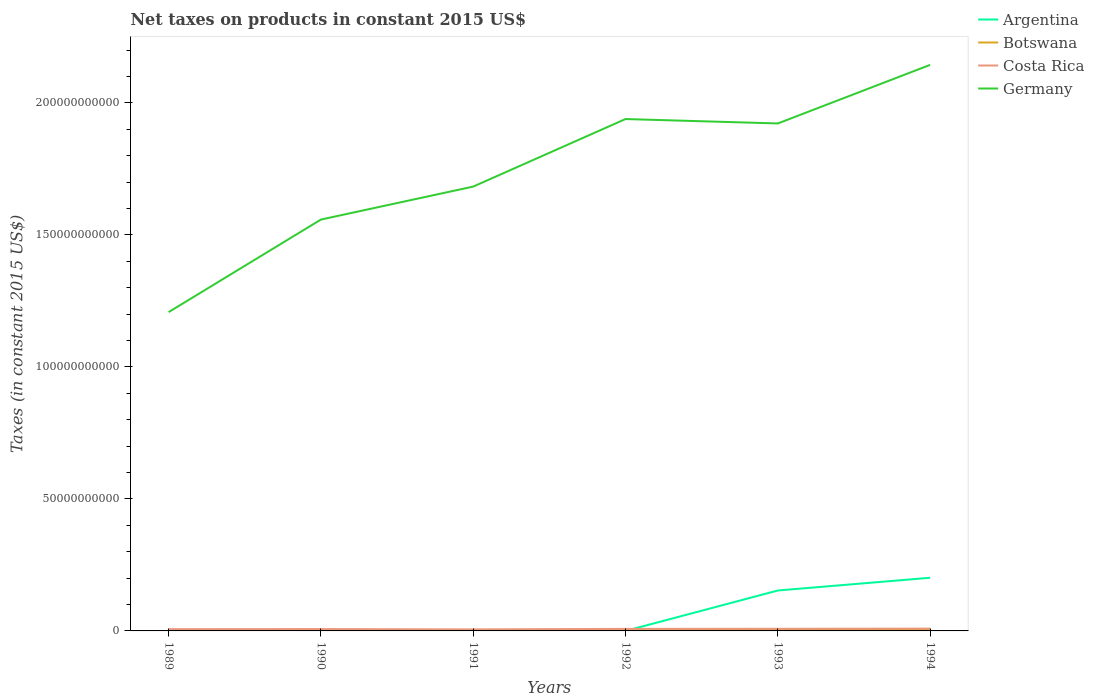Does the line corresponding to Germany intersect with the line corresponding to Argentina?
Ensure brevity in your answer.  No. Is the number of lines equal to the number of legend labels?
Your response must be concise. No. Across all years, what is the maximum net taxes on products in Costa Rica?
Ensure brevity in your answer.  5.75e+08. What is the total net taxes on products in Costa Rica in the graph?
Your answer should be compact. -5.16e+07. What is the difference between the highest and the second highest net taxes on products in Argentina?
Offer a very short reply. 2.01e+1. What is the difference between the highest and the lowest net taxes on products in Botswana?
Your answer should be very brief. 4. How many years are there in the graph?
Make the answer very short. 6. What is the difference between two consecutive major ticks on the Y-axis?
Ensure brevity in your answer.  5.00e+1. Are the values on the major ticks of Y-axis written in scientific E-notation?
Ensure brevity in your answer.  No. How many legend labels are there?
Make the answer very short. 4. How are the legend labels stacked?
Your answer should be compact. Vertical. What is the title of the graph?
Make the answer very short. Net taxes on products in constant 2015 US$. What is the label or title of the X-axis?
Give a very brief answer. Years. What is the label or title of the Y-axis?
Provide a succinct answer. Taxes (in constant 2015 US$). What is the Taxes (in constant 2015 US$) of Botswana in 1989?
Provide a short and direct response. 1.67e+08. What is the Taxes (in constant 2015 US$) of Costa Rica in 1989?
Make the answer very short. 6.61e+08. What is the Taxes (in constant 2015 US$) of Germany in 1989?
Offer a very short reply. 1.21e+11. What is the Taxes (in constant 2015 US$) of Botswana in 1990?
Give a very brief answer. 2.56e+08. What is the Taxes (in constant 2015 US$) of Costa Rica in 1990?
Offer a terse response. 7.13e+08. What is the Taxes (in constant 2015 US$) in Germany in 1990?
Keep it short and to the point. 1.56e+11. What is the Taxes (in constant 2015 US$) of Argentina in 1991?
Keep it short and to the point. 314.63. What is the Taxes (in constant 2015 US$) of Botswana in 1991?
Keep it short and to the point. 3.61e+08. What is the Taxes (in constant 2015 US$) of Costa Rica in 1991?
Your answer should be very brief. 5.75e+08. What is the Taxes (in constant 2015 US$) in Germany in 1991?
Your answer should be very brief. 1.68e+11. What is the Taxes (in constant 2015 US$) of Argentina in 1992?
Provide a short and direct response. 0. What is the Taxes (in constant 2015 US$) in Botswana in 1992?
Offer a terse response. 4.56e+08. What is the Taxes (in constant 2015 US$) in Costa Rica in 1992?
Your answer should be compact. 7.75e+08. What is the Taxes (in constant 2015 US$) in Germany in 1992?
Provide a short and direct response. 1.94e+11. What is the Taxes (in constant 2015 US$) of Argentina in 1993?
Make the answer very short. 1.53e+1. What is the Taxes (in constant 2015 US$) of Botswana in 1993?
Offer a very short reply. 4.05e+08. What is the Taxes (in constant 2015 US$) in Costa Rica in 1993?
Provide a succinct answer. 8.03e+08. What is the Taxes (in constant 2015 US$) of Germany in 1993?
Your answer should be very brief. 1.92e+11. What is the Taxes (in constant 2015 US$) of Argentina in 1994?
Offer a terse response. 2.01e+1. What is the Taxes (in constant 2015 US$) in Botswana in 1994?
Provide a short and direct response. 3.37e+08. What is the Taxes (in constant 2015 US$) in Costa Rica in 1994?
Keep it short and to the point. 8.78e+08. What is the Taxes (in constant 2015 US$) in Germany in 1994?
Give a very brief answer. 2.14e+11. Across all years, what is the maximum Taxes (in constant 2015 US$) of Argentina?
Keep it short and to the point. 2.01e+1. Across all years, what is the maximum Taxes (in constant 2015 US$) in Botswana?
Your answer should be very brief. 4.56e+08. Across all years, what is the maximum Taxes (in constant 2015 US$) of Costa Rica?
Keep it short and to the point. 8.78e+08. Across all years, what is the maximum Taxes (in constant 2015 US$) of Germany?
Give a very brief answer. 2.14e+11. Across all years, what is the minimum Taxes (in constant 2015 US$) of Botswana?
Your answer should be compact. 1.67e+08. Across all years, what is the minimum Taxes (in constant 2015 US$) in Costa Rica?
Keep it short and to the point. 5.75e+08. Across all years, what is the minimum Taxes (in constant 2015 US$) in Germany?
Provide a succinct answer. 1.21e+11. What is the total Taxes (in constant 2015 US$) in Argentina in the graph?
Make the answer very short. 3.54e+1. What is the total Taxes (in constant 2015 US$) of Botswana in the graph?
Provide a succinct answer. 1.98e+09. What is the total Taxes (in constant 2015 US$) of Costa Rica in the graph?
Provide a short and direct response. 4.40e+09. What is the total Taxes (in constant 2015 US$) of Germany in the graph?
Your response must be concise. 1.05e+12. What is the difference between the Taxes (in constant 2015 US$) in Botswana in 1989 and that in 1990?
Keep it short and to the point. -8.81e+07. What is the difference between the Taxes (in constant 2015 US$) in Costa Rica in 1989 and that in 1990?
Provide a short and direct response. -5.16e+07. What is the difference between the Taxes (in constant 2015 US$) in Germany in 1989 and that in 1990?
Provide a succinct answer. -3.51e+1. What is the difference between the Taxes (in constant 2015 US$) of Botswana in 1989 and that in 1991?
Your answer should be compact. -1.93e+08. What is the difference between the Taxes (in constant 2015 US$) of Costa Rica in 1989 and that in 1991?
Offer a very short reply. 8.65e+07. What is the difference between the Taxes (in constant 2015 US$) in Germany in 1989 and that in 1991?
Ensure brevity in your answer.  -4.75e+1. What is the difference between the Taxes (in constant 2015 US$) of Botswana in 1989 and that in 1992?
Offer a terse response. -2.88e+08. What is the difference between the Taxes (in constant 2015 US$) of Costa Rica in 1989 and that in 1992?
Make the answer very short. -1.13e+08. What is the difference between the Taxes (in constant 2015 US$) of Germany in 1989 and that in 1992?
Keep it short and to the point. -7.31e+1. What is the difference between the Taxes (in constant 2015 US$) in Botswana in 1989 and that in 1993?
Provide a short and direct response. -2.38e+08. What is the difference between the Taxes (in constant 2015 US$) in Costa Rica in 1989 and that in 1993?
Offer a very short reply. -1.42e+08. What is the difference between the Taxes (in constant 2015 US$) in Germany in 1989 and that in 1993?
Your answer should be very brief. -7.15e+1. What is the difference between the Taxes (in constant 2015 US$) in Botswana in 1989 and that in 1994?
Keep it short and to the point. -1.70e+08. What is the difference between the Taxes (in constant 2015 US$) of Costa Rica in 1989 and that in 1994?
Your answer should be very brief. -2.17e+08. What is the difference between the Taxes (in constant 2015 US$) of Germany in 1989 and that in 1994?
Ensure brevity in your answer.  -9.36e+1. What is the difference between the Taxes (in constant 2015 US$) of Botswana in 1990 and that in 1991?
Make the answer very short. -1.05e+08. What is the difference between the Taxes (in constant 2015 US$) of Costa Rica in 1990 and that in 1991?
Your answer should be very brief. 1.38e+08. What is the difference between the Taxes (in constant 2015 US$) in Germany in 1990 and that in 1991?
Give a very brief answer. -1.25e+1. What is the difference between the Taxes (in constant 2015 US$) of Botswana in 1990 and that in 1992?
Give a very brief answer. -2.00e+08. What is the difference between the Taxes (in constant 2015 US$) in Costa Rica in 1990 and that in 1992?
Provide a succinct answer. -6.17e+07. What is the difference between the Taxes (in constant 2015 US$) in Germany in 1990 and that in 1992?
Your response must be concise. -3.81e+1. What is the difference between the Taxes (in constant 2015 US$) in Botswana in 1990 and that in 1993?
Ensure brevity in your answer.  -1.50e+08. What is the difference between the Taxes (in constant 2015 US$) of Costa Rica in 1990 and that in 1993?
Ensure brevity in your answer.  -9.05e+07. What is the difference between the Taxes (in constant 2015 US$) in Germany in 1990 and that in 1993?
Make the answer very short. -3.64e+1. What is the difference between the Taxes (in constant 2015 US$) in Botswana in 1990 and that in 1994?
Provide a succinct answer. -8.17e+07. What is the difference between the Taxes (in constant 2015 US$) in Costa Rica in 1990 and that in 1994?
Your answer should be very brief. -1.65e+08. What is the difference between the Taxes (in constant 2015 US$) in Germany in 1990 and that in 1994?
Your response must be concise. -5.86e+1. What is the difference between the Taxes (in constant 2015 US$) of Botswana in 1991 and that in 1992?
Your answer should be compact. -9.52e+07. What is the difference between the Taxes (in constant 2015 US$) in Costa Rica in 1991 and that in 1992?
Your answer should be very brief. -2.00e+08. What is the difference between the Taxes (in constant 2015 US$) in Germany in 1991 and that in 1992?
Ensure brevity in your answer.  -2.56e+1. What is the difference between the Taxes (in constant 2015 US$) of Argentina in 1991 and that in 1993?
Your response must be concise. -1.53e+1. What is the difference between the Taxes (in constant 2015 US$) in Botswana in 1991 and that in 1993?
Your answer should be compact. -4.47e+07. What is the difference between the Taxes (in constant 2015 US$) in Costa Rica in 1991 and that in 1993?
Provide a short and direct response. -2.29e+08. What is the difference between the Taxes (in constant 2015 US$) of Germany in 1991 and that in 1993?
Your answer should be compact. -2.39e+1. What is the difference between the Taxes (in constant 2015 US$) of Argentina in 1991 and that in 1994?
Provide a succinct answer. -2.01e+1. What is the difference between the Taxes (in constant 2015 US$) of Botswana in 1991 and that in 1994?
Ensure brevity in your answer.  2.34e+07. What is the difference between the Taxes (in constant 2015 US$) in Costa Rica in 1991 and that in 1994?
Ensure brevity in your answer.  -3.03e+08. What is the difference between the Taxes (in constant 2015 US$) of Germany in 1991 and that in 1994?
Your answer should be compact. -4.61e+1. What is the difference between the Taxes (in constant 2015 US$) of Botswana in 1992 and that in 1993?
Make the answer very short. 5.05e+07. What is the difference between the Taxes (in constant 2015 US$) in Costa Rica in 1992 and that in 1993?
Your answer should be very brief. -2.88e+07. What is the difference between the Taxes (in constant 2015 US$) in Germany in 1992 and that in 1993?
Your answer should be compact. 1.67e+09. What is the difference between the Taxes (in constant 2015 US$) of Botswana in 1992 and that in 1994?
Provide a succinct answer. 1.19e+08. What is the difference between the Taxes (in constant 2015 US$) of Costa Rica in 1992 and that in 1994?
Offer a terse response. -1.04e+08. What is the difference between the Taxes (in constant 2015 US$) in Germany in 1992 and that in 1994?
Provide a succinct answer. -2.05e+1. What is the difference between the Taxes (in constant 2015 US$) in Argentina in 1993 and that in 1994?
Ensure brevity in your answer.  -4.82e+09. What is the difference between the Taxes (in constant 2015 US$) of Botswana in 1993 and that in 1994?
Offer a terse response. 6.81e+07. What is the difference between the Taxes (in constant 2015 US$) of Costa Rica in 1993 and that in 1994?
Keep it short and to the point. -7.48e+07. What is the difference between the Taxes (in constant 2015 US$) of Germany in 1993 and that in 1994?
Offer a very short reply. -2.22e+1. What is the difference between the Taxes (in constant 2015 US$) in Botswana in 1989 and the Taxes (in constant 2015 US$) in Costa Rica in 1990?
Offer a terse response. -5.45e+08. What is the difference between the Taxes (in constant 2015 US$) in Botswana in 1989 and the Taxes (in constant 2015 US$) in Germany in 1990?
Provide a succinct answer. -1.56e+11. What is the difference between the Taxes (in constant 2015 US$) of Costa Rica in 1989 and the Taxes (in constant 2015 US$) of Germany in 1990?
Your answer should be compact. -1.55e+11. What is the difference between the Taxes (in constant 2015 US$) in Botswana in 1989 and the Taxes (in constant 2015 US$) in Costa Rica in 1991?
Provide a short and direct response. -4.07e+08. What is the difference between the Taxes (in constant 2015 US$) of Botswana in 1989 and the Taxes (in constant 2015 US$) of Germany in 1991?
Your answer should be compact. -1.68e+11. What is the difference between the Taxes (in constant 2015 US$) in Costa Rica in 1989 and the Taxes (in constant 2015 US$) in Germany in 1991?
Provide a short and direct response. -1.68e+11. What is the difference between the Taxes (in constant 2015 US$) in Botswana in 1989 and the Taxes (in constant 2015 US$) in Costa Rica in 1992?
Provide a succinct answer. -6.07e+08. What is the difference between the Taxes (in constant 2015 US$) in Botswana in 1989 and the Taxes (in constant 2015 US$) in Germany in 1992?
Provide a short and direct response. -1.94e+11. What is the difference between the Taxes (in constant 2015 US$) of Costa Rica in 1989 and the Taxes (in constant 2015 US$) of Germany in 1992?
Provide a short and direct response. -1.93e+11. What is the difference between the Taxes (in constant 2015 US$) of Botswana in 1989 and the Taxes (in constant 2015 US$) of Costa Rica in 1993?
Give a very brief answer. -6.36e+08. What is the difference between the Taxes (in constant 2015 US$) of Botswana in 1989 and the Taxes (in constant 2015 US$) of Germany in 1993?
Your response must be concise. -1.92e+11. What is the difference between the Taxes (in constant 2015 US$) in Costa Rica in 1989 and the Taxes (in constant 2015 US$) in Germany in 1993?
Offer a very short reply. -1.92e+11. What is the difference between the Taxes (in constant 2015 US$) in Botswana in 1989 and the Taxes (in constant 2015 US$) in Costa Rica in 1994?
Keep it short and to the point. -7.11e+08. What is the difference between the Taxes (in constant 2015 US$) in Botswana in 1989 and the Taxes (in constant 2015 US$) in Germany in 1994?
Ensure brevity in your answer.  -2.14e+11. What is the difference between the Taxes (in constant 2015 US$) in Costa Rica in 1989 and the Taxes (in constant 2015 US$) in Germany in 1994?
Provide a short and direct response. -2.14e+11. What is the difference between the Taxes (in constant 2015 US$) of Botswana in 1990 and the Taxes (in constant 2015 US$) of Costa Rica in 1991?
Ensure brevity in your answer.  -3.19e+08. What is the difference between the Taxes (in constant 2015 US$) of Botswana in 1990 and the Taxes (in constant 2015 US$) of Germany in 1991?
Give a very brief answer. -1.68e+11. What is the difference between the Taxes (in constant 2015 US$) of Costa Rica in 1990 and the Taxes (in constant 2015 US$) of Germany in 1991?
Provide a short and direct response. -1.68e+11. What is the difference between the Taxes (in constant 2015 US$) in Botswana in 1990 and the Taxes (in constant 2015 US$) in Costa Rica in 1992?
Keep it short and to the point. -5.19e+08. What is the difference between the Taxes (in constant 2015 US$) of Botswana in 1990 and the Taxes (in constant 2015 US$) of Germany in 1992?
Ensure brevity in your answer.  -1.94e+11. What is the difference between the Taxes (in constant 2015 US$) of Costa Rica in 1990 and the Taxes (in constant 2015 US$) of Germany in 1992?
Offer a very short reply. -1.93e+11. What is the difference between the Taxes (in constant 2015 US$) of Botswana in 1990 and the Taxes (in constant 2015 US$) of Costa Rica in 1993?
Provide a succinct answer. -5.48e+08. What is the difference between the Taxes (in constant 2015 US$) in Botswana in 1990 and the Taxes (in constant 2015 US$) in Germany in 1993?
Your answer should be very brief. -1.92e+11. What is the difference between the Taxes (in constant 2015 US$) in Costa Rica in 1990 and the Taxes (in constant 2015 US$) in Germany in 1993?
Your response must be concise. -1.91e+11. What is the difference between the Taxes (in constant 2015 US$) of Botswana in 1990 and the Taxes (in constant 2015 US$) of Costa Rica in 1994?
Ensure brevity in your answer.  -6.23e+08. What is the difference between the Taxes (in constant 2015 US$) of Botswana in 1990 and the Taxes (in constant 2015 US$) of Germany in 1994?
Offer a terse response. -2.14e+11. What is the difference between the Taxes (in constant 2015 US$) in Costa Rica in 1990 and the Taxes (in constant 2015 US$) in Germany in 1994?
Provide a short and direct response. -2.14e+11. What is the difference between the Taxes (in constant 2015 US$) in Argentina in 1991 and the Taxes (in constant 2015 US$) in Botswana in 1992?
Make the answer very short. -4.56e+08. What is the difference between the Taxes (in constant 2015 US$) of Argentina in 1991 and the Taxes (in constant 2015 US$) of Costa Rica in 1992?
Your answer should be compact. -7.75e+08. What is the difference between the Taxes (in constant 2015 US$) in Argentina in 1991 and the Taxes (in constant 2015 US$) in Germany in 1992?
Offer a terse response. -1.94e+11. What is the difference between the Taxes (in constant 2015 US$) in Botswana in 1991 and the Taxes (in constant 2015 US$) in Costa Rica in 1992?
Your answer should be compact. -4.14e+08. What is the difference between the Taxes (in constant 2015 US$) of Botswana in 1991 and the Taxes (in constant 2015 US$) of Germany in 1992?
Keep it short and to the point. -1.94e+11. What is the difference between the Taxes (in constant 2015 US$) in Costa Rica in 1991 and the Taxes (in constant 2015 US$) in Germany in 1992?
Offer a very short reply. -1.93e+11. What is the difference between the Taxes (in constant 2015 US$) in Argentina in 1991 and the Taxes (in constant 2015 US$) in Botswana in 1993?
Provide a succinct answer. -4.05e+08. What is the difference between the Taxes (in constant 2015 US$) of Argentina in 1991 and the Taxes (in constant 2015 US$) of Costa Rica in 1993?
Provide a succinct answer. -8.03e+08. What is the difference between the Taxes (in constant 2015 US$) of Argentina in 1991 and the Taxes (in constant 2015 US$) of Germany in 1993?
Offer a terse response. -1.92e+11. What is the difference between the Taxes (in constant 2015 US$) of Botswana in 1991 and the Taxes (in constant 2015 US$) of Costa Rica in 1993?
Your response must be concise. -4.43e+08. What is the difference between the Taxes (in constant 2015 US$) in Botswana in 1991 and the Taxes (in constant 2015 US$) in Germany in 1993?
Your response must be concise. -1.92e+11. What is the difference between the Taxes (in constant 2015 US$) in Costa Rica in 1991 and the Taxes (in constant 2015 US$) in Germany in 1993?
Keep it short and to the point. -1.92e+11. What is the difference between the Taxes (in constant 2015 US$) of Argentina in 1991 and the Taxes (in constant 2015 US$) of Botswana in 1994?
Make the answer very short. -3.37e+08. What is the difference between the Taxes (in constant 2015 US$) of Argentina in 1991 and the Taxes (in constant 2015 US$) of Costa Rica in 1994?
Your answer should be very brief. -8.78e+08. What is the difference between the Taxes (in constant 2015 US$) of Argentina in 1991 and the Taxes (in constant 2015 US$) of Germany in 1994?
Your answer should be very brief. -2.14e+11. What is the difference between the Taxes (in constant 2015 US$) of Botswana in 1991 and the Taxes (in constant 2015 US$) of Costa Rica in 1994?
Make the answer very short. -5.17e+08. What is the difference between the Taxes (in constant 2015 US$) of Botswana in 1991 and the Taxes (in constant 2015 US$) of Germany in 1994?
Make the answer very short. -2.14e+11. What is the difference between the Taxes (in constant 2015 US$) in Costa Rica in 1991 and the Taxes (in constant 2015 US$) in Germany in 1994?
Offer a terse response. -2.14e+11. What is the difference between the Taxes (in constant 2015 US$) in Botswana in 1992 and the Taxes (in constant 2015 US$) in Costa Rica in 1993?
Give a very brief answer. -3.48e+08. What is the difference between the Taxes (in constant 2015 US$) in Botswana in 1992 and the Taxes (in constant 2015 US$) in Germany in 1993?
Offer a very short reply. -1.92e+11. What is the difference between the Taxes (in constant 2015 US$) in Costa Rica in 1992 and the Taxes (in constant 2015 US$) in Germany in 1993?
Ensure brevity in your answer.  -1.91e+11. What is the difference between the Taxes (in constant 2015 US$) of Botswana in 1992 and the Taxes (in constant 2015 US$) of Costa Rica in 1994?
Your response must be concise. -4.22e+08. What is the difference between the Taxes (in constant 2015 US$) of Botswana in 1992 and the Taxes (in constant 2015 US$) of Germany in 1994?
Provide a succinct answer. -2.14e+11. What is the difference between the Taxes (in constant 2015 US$) of Costa Rica in 1992 and the Taxes (in constant 2015 US$) of Germany in 1994?
Ensure brevity in your answer.  -2.14e+11. What is the difference between the Taxes (in constant 2015 US$) of Argentina in 1993 and the Taxes (in constant 2015 US$) of Botswana in 1994?
Give a very brief answer. 1.50e+1. What is the difference between the Taxes (in constant 2015 US$) in Argentina in 1993 and the Taxes (in constant 2015 US$) in Costa Rica in 1994?
Provide a short and direct response. 1.44e+1. What is the difference between the Taxes (in constant 2015 US$) of Argentina in 1993 and the Taxes (in constant 2015 US$) of Germany in 1994?
Your answer should be very brief. -1.99e+11. What is the difference between the Taxes (in constant 2015 US$) in Botswana in 1993 and the Taxes (in constant 2015 US$) in Costa Rica in 1994?
Offer a terse response. -4.73e+08. What is the difference between the Taxes (in constant 2015 US$) in Botswana in 1993 and the Taxes (in constant 2015 US$) in Germany in 1994?
Your answer should be very brief. -2.14e+11. What is the difference between the Taxes (in constant 2015 US$) of Costa Rica in 1993 and the Taxes (in constant 2015 US$) of Germany in 1994?
Keep it short and to the point. -2.14e+11. What is the average Taxes (in constant 2015 US$) of Argentina per year?
Ensure brevity in your answer.  5.91e+09. What is the average Taxes (in constant 2015 US$) of Botswana per year?
Keep it short and to the point. 3.30e+08. What is the average Taxes (in constant 2015 US$) in Costa Rica per year?
Ensure brevity in your answer.  7.34e+08. What is the average Taxes (in constant 2015 US$) of Germany per year?
Offer a very short reply. 1.74e+11. In the year 1989, what is the difference between the Taxes (in constant 2015 US$) in Botswana and Taxes (in constant 2015 US$) in Costa Rica?
Keep it short and to the point. -4.94e+08. In the year 1989, what is the difference between the Taxes (in constant 2015 US$) in Botswana and Taxes (in constant 2015 US$) in Germany?
Make the answer very short. -1.21e+11. In the year 1989, what is the difference between the Taxes (in constant 2015 US$) of Costa Rica and Taxes (in constant 2015 US$) of Germany?
Offer a very short reply. -1.20e+11. In the year 1990, what is the difference between the Taxes (in constant 2015 US$) of Botswana and Taxes (in constant 2015 US$) of Costa Rica?
Your answer should be very brief. -4.57e+08. In the year 1990, what is the difference between the Taxes (in constant 2015 US$) of Botswana and Taxes (in constant 2015 US$) of Germany?
Offer a very short reply. -1.56e+11. In the year 1990, what is the difference between the Taxes (in constant 2015 US$) in Costa Rica and Taxes (in constant 2015 US$) in Germany?
Provide a succinct answer. -1.55e+11. In the year 1991, what is the difference between the Taxes (in constant 2015 US$) of Argentina and Taxes (in constant 2015 US$) of Botswana?
Provide a short and direct response. -3.61e+08. In the year 1991, what is the difference between the Taxes (in constant 2015 US$) of Argentina and Taxes (in constant 2015 US$) of Costa Rica?
Provide a succinct answer. -5.75e+08. In the year 1991, what is the difference between the Taxes (in constant 2015 US$) of Argentina and Taxes (in constant 2015 US$) of Germany?
Your response must be concise. -1.68e+11. In the year 1991, what is the difference between the Taxes (in constant 2015 US$) of Botswana and Taxes (in constant 2015 US$) of Costa Rica?
Give a very brief answer. -2.14e+08. In the year 1991, what is the difference between the Taxes (in constant 2015 US$) in Botswana and Taxes (in constant 2015 US$) in Germany?
Your answer should be compact. -1.68e+11. In the year 1991, what is the difference between the Taxes (in constant 2015 US$) of Costa Rica and Taxes (in constant 2015 US$) of Germany?
Ensure brevity in your answer.  -1.68e+11. In the year 1992, what is the difference between the Taxes (in constant 2015 US$) in Botswana and Taxes (in constant 2015 US$) in Costa Rica?
Make the answer very short. -3.19e+08. In the year 1992, what is the difference between the Taxes (in constant 2015 US$) of Botswana and Taxes (in constant 2015 US$) of Germany?
Ensure brevity in your answer.  -1.93e+11. In the year 1992, what is the difference between the Taxes (in constant 2015 US$) in Costa Rica and Taxes (in constant 2015 US$) in Germany?
Give a very brief answer. -1.93e+11. In the year 1993, what is the difference between the Taxes (in constant 2015 US$) in Argentina and Taxes (in constant 2015 US$) in Botswana?
Give a very brief answer. 1.49e+1. In the year 1993, what is the difference between the Taxes (in constant 2015 US$) in Argentina and Taxes (in constant 2015 US$) in Costa Rica?
Give a very brief answer. 1.45e+1. In the year 1993, what is the difference between the Taxes (in constant 2015 US$) of Argentina and Taxes (in constant 2015 US$) of Germany?
Ensure brevity in your answer.  -1.77e+11. In the year 1993, what is the difference between the Taxes (in constant 2015 US$) of Botswana and Taxes (in constant 2015 US$) of Costa Rica?
Your answer should be very brief. -3.98e+08. In the year 1993, what is the difference between the Taxes (in constant 2015 US$) in Botswana and Taxes (in constant 2015 US$) in Germany?
Give a very brief answer. -1.92e+11. In the year 1993, what is the difference between the Taxes (in constant 2015 US$) in Costa Rica and Taxes (in constant 2015 US$) in Germany?
Keep it short and to the point. -1.91e+11. In the year 1994, what is the difference between the Taxes (in constant 2015 US$) of Argentina and Taxes (in constant 2015 US$) of Botswana?
Make the answer very short. 1.98e+1. In the year 1994, what is the difference between the Taxes (in constant 2015 US$) in Argentina and Taxes (in constant 2015 US$) in Costa Rica?
Provide a succinct answer. 1.93e+1. In the year 1994, what is the difference between the Taxes (in constant 2015 US$) of Argentina and Taxes (in constant 2015 US$) of Germany?
Provide a succinct answer. -1.94e+11. In the year 1994, what is the difference between the Taxes (in constant 2015 US$) in Botswana and Taxes (in constant 2015 US$) in Costa Rica?
Ensure brevity in your answer.  -5.41e+08. In the year 1994, what is the difference between the Taxes (in constant 2015 US$) of Botswana and Taxes (in constant 2015 US$) of Germany?
Keep it short and to the point. -2.14e+11. In the year 1994, what is the difference between the Taxes (in constant 2015 US$) of Costa Rica and Taxes (in constant 2015 US$) of Germany?
Give a very brief answer. -2.14e+11. What is the ratio of the Taxes (in constant 2015 US$) of Botswana in 1989 to that in 1990?
Offer a terse response. 0.66. What is the ratio of the Taxes (in constant 2015 US$) in Costa Rica in 1989 to that in 1990?
Provide a succinct answer. 0.93. What is the ratio of the Taxes (in constant 2015 US$) of Germany in 1989 to that in 1990?
Offer a terse response. 0.78. What is the ratio of the Taxes (in constant 2015 US$) of Botswana in 1989 to that in 1991?
Your answer should be compact. 0.46. What is the ratio of the Taxes (in constant 2015 US$) of Costa Rica in 1989 to that in 1991?
Your answer should be compact. 1.15. What is the ratio of the Taxes (in constant 2015 US$) in Germany in 1989 to that in 1991?
Make the answer very short. 0.72. What is the ratio of the Taxes (in constant 2015 US$) in Botswana in 1989 to that in 1992?
Make the answer very short. 0.37. What is the ratio of the Taxes (in constant 2015 US$) in Costa Rica in 1989 to that in 1992?
Make the answer very short. 0.85. What is the ratio of the Taxes (in constant 2015 US$) of Germany in 1989 to that in 1992?
Keep it short and to the point. 0.62. What is the ratio of the Taxes (in constant 2015 US$) of Botswana in 1989 to that in 1993?
Keep it short and to the point. 0.41. What is the ratio of the Taxes (in constant 2015 US$) in Costa Rica in 1989 to that in 1993?
Give a very brief answer. 0.82. What is the ratio of the Taxes (in constant 2015 US$) in Germany in 1989 to that in 1993?
Provide a succinct answer. 0.63. What is the ratio of the Taxes (in constant 2015 US$) of Botswana in 1989 to that in 1994?
Provide a succinct answer. 0.5. What is the ratio of the Taxes (in constant 2015 US$) in Costa Rica in 1989 to that in 1994?
Your answer should be compact. 0.75. What is the ratio of the Taxes (in constant 2015 US$) of Germany in 1989 to that in 1994?
Your response must be concise. 0.56. What is the ratio of the Taxes (in constant 2015 US$) in Botswana in 1990 to that in 1991?
Give a very brief answer. 0.71. What is the ratio of the Taxes (in constant 2015 US$) in Costa Rica in 1990 to that in 1991?
Ensure brevity in your answer.  1.24. What is the ratio of the Taxes (in constant 2015 US$) of Germany in 1990 to that in 1991?
Make the answer very short. 0.93. What is the ratio of the Taxes (in constant 2015 US$) in Botswana in 1990 to that in 1992?
Make the answer very short. 0.56. What is the ratio of the Taxes (in constant 2015 US$) of Costa Rica in 1990 to that in 1992?
Offer a terse response. 0.92. What is the ratio of the Taxes (in constant 2015 US$) in Germany in 1990 to that in 1992?
Your answer should be compact. 0.8. What is the ratio of the Taxes (in constant 2015 US$) of Botswana in 1990 to that in 1993?
Keep it short and to the point. 0.63. What is the ratio of the Taxes (in constant 2015 US$) in Costa Rica in 1990 to that in 1993?
Your response must be concise. 0.89. What is the ratio of the Taxes (in constant 2015 US$) in Germany in 1990 to that in 1993?
Give a very brief answer. 0.81. What is the ratio of the Taxes (in constant 2015 US$) of Botswana in 1990 to that in 1994?
Keep it short and to the point. 0.76. What is the ratio of the Taxes (in constant 2015 US$) of Costa Rica in 1990 to that in 1994?
Your answer should be very brief. 0.81. What is the ratio of the Taxes (in constant 2015 US$) of Germany in 1990 to that in 1994?
Offer a very short reply. 0.73. What is the ratio of the Taxes (in constant 2015 US$) in Botswana in 1991 to that in 1992?
Offer a very short reply. 0.79. What is the ratio of the Taxes (in constant 2015 US$) of Costa Rica in 1991 to that in 1992?
Your answer should be very brief. 0.74. What is the ratio of the Taxes (in constant 2015 US$) of Germany in 1991 to that in 1992?
Ensure brevity in your answer.  0.87. What is the ratio of the Taxes (in constant 2015 US$) in Botswana in 1991 to that in 1993?
Offer a terse response. 0.89. What is the ratio of the Taxes (in constant 2015 US$) in Costa Rica in 1991 to that in 1993?
Your answer should be very brief. 0.72. What is the ratio of the Taxes (in constant 2015 US$) in Germany in 1991 to that in 1993?
Provide a short and direct response. 0.88. What is the ratio of the Taxes (in constant 2015 US$) of Argentina in 1991 to that in 1994?
Your answer should be compact. 0. What is the ratio of the Taxes (in constant 2015 US$) of Botswana in 1991 to that in 1994?
Your answer should be compact. 1.07. What is the ratio of the Taxes (in constant 2015 US$) of Costa Rica in 1991 to that in 1994?
Provide a short and direct response. 0.65. What is the ratio of the Taxes (in constant 2015 US$) in Germany in 1991 to that in 1994?
Your answer should be compact. 0.79. What is the ratio of the Taxes (in constant 2015 US$) in Botswana in 1992 to that in 1993?
Your response must be concise. 1.12. What is the ratio of the Taxes (in constant 2015 US$) of Costa Rica in 1992 to that in 1993?
Offer a very short reply. 0.96. What is the ratio of the Taxes (in constant 2015 US$) in Germany in 1992 to that in 1993?
Give a very brief answer. 1.01. What is the ratio of the Taxes (in constant 2015 US$) of Botswana in 1992 to that in 1994?
Your answer should be very brief. 1.35. What is the ratio of the Taxes (in constant 2015 US$) in Costa Rica in 1992 to that in 1994?
Provide a short and direct response. 0.88. What is the ratio of the Taxes (in constant 2015 US$) of Germany in 1992 to that in 1994?
Your response must be concise. 0.9. What is the ratio of the Taxes (in constant 2015 US$) of Argentina in 1993 to that in 1994?
Make the answer very short. 0.76. What is the ratio of the Taxes (in constant 2015 US$) of Botswana in 1993 to that in 1994?
Provide a succinct answer. 1.2. What is the ratio of the Taxes (in constant 2015 US$) in Costa Rica in 1993 to that in 1994?
Give a very brief answer. 0.91. What is the ratio of the Taxes (in constant 2015 US$) in Germany in 1993 to that in 1994?
Offer a terse response. 0.9. What is the difference between the highest and the second highest Taxes (in constant 2015 US$) of Argentina?
Provide a short and direct response. 4.82e+09. What is the difference between the highest and the second highest Taxes (in constant 2015 US$) in Botswana?
Ensure brevity in your answer.  5.05e+07. What is the difference between the highest and the second highest Taxes (in constant 2015 US$) in Costa Rica?
Provide a short and direct response. 7.48e+07. What is the difference between the highest and the second highest Taxes (in constant 2015 US$) of Germany?
Your answer should be compact. 2.05e+1. What is the difference between the highest and the lowest Taxes (in constant 2015 US$) of Argentina?
Provide a short and direct response. 2.01e+1. What is the difference between the highest and the lowest Taxes (in constant 2015 US$) of Botswana?
Keep it short and to the point. 2.88e+08. What is the difference between the highest and the lowest Taxes (in constant 2015 US$) in Costa Rica?
Make the answer very short. 3.03e+08. What is the difference between the highest and the lowest Taxes (in constant 2015 US$) of Germany?
Ensure brevity in your answer.  9.36e+1. 